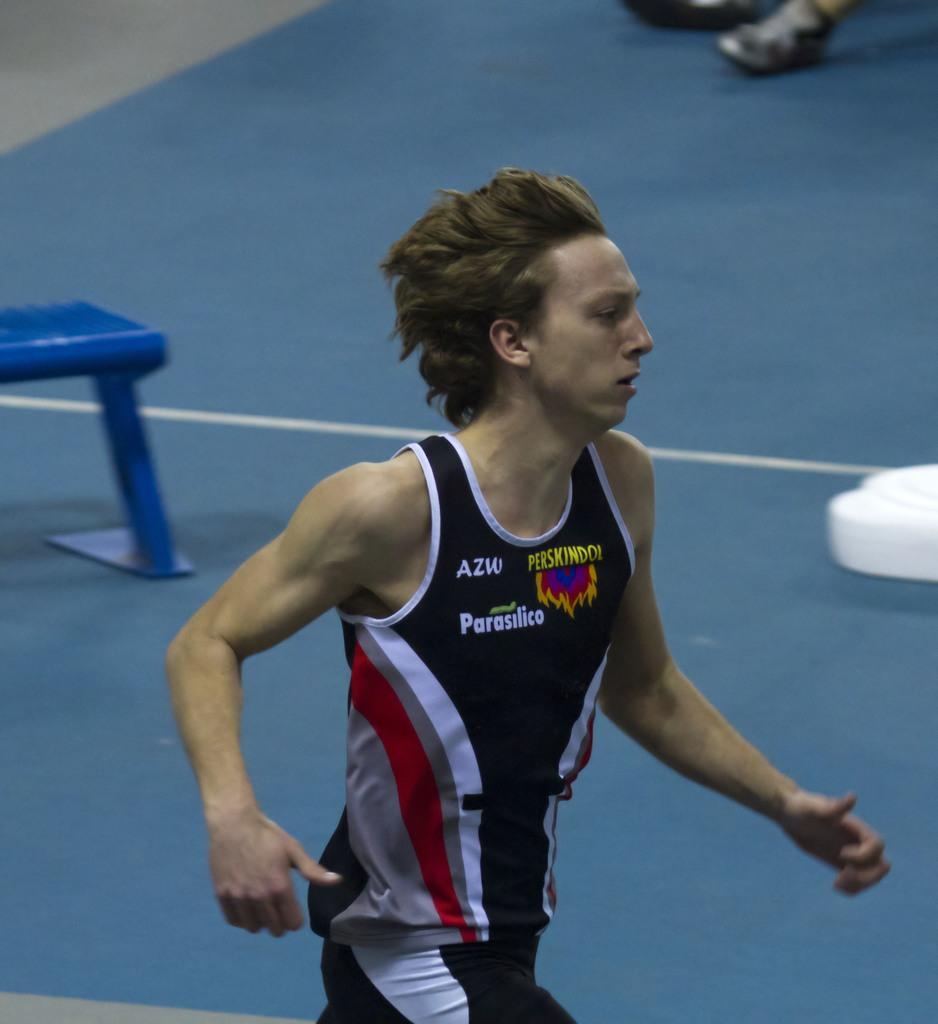<image>
Offer a succinct explanation of the picture presented. a man that has on an AZW running shirt 